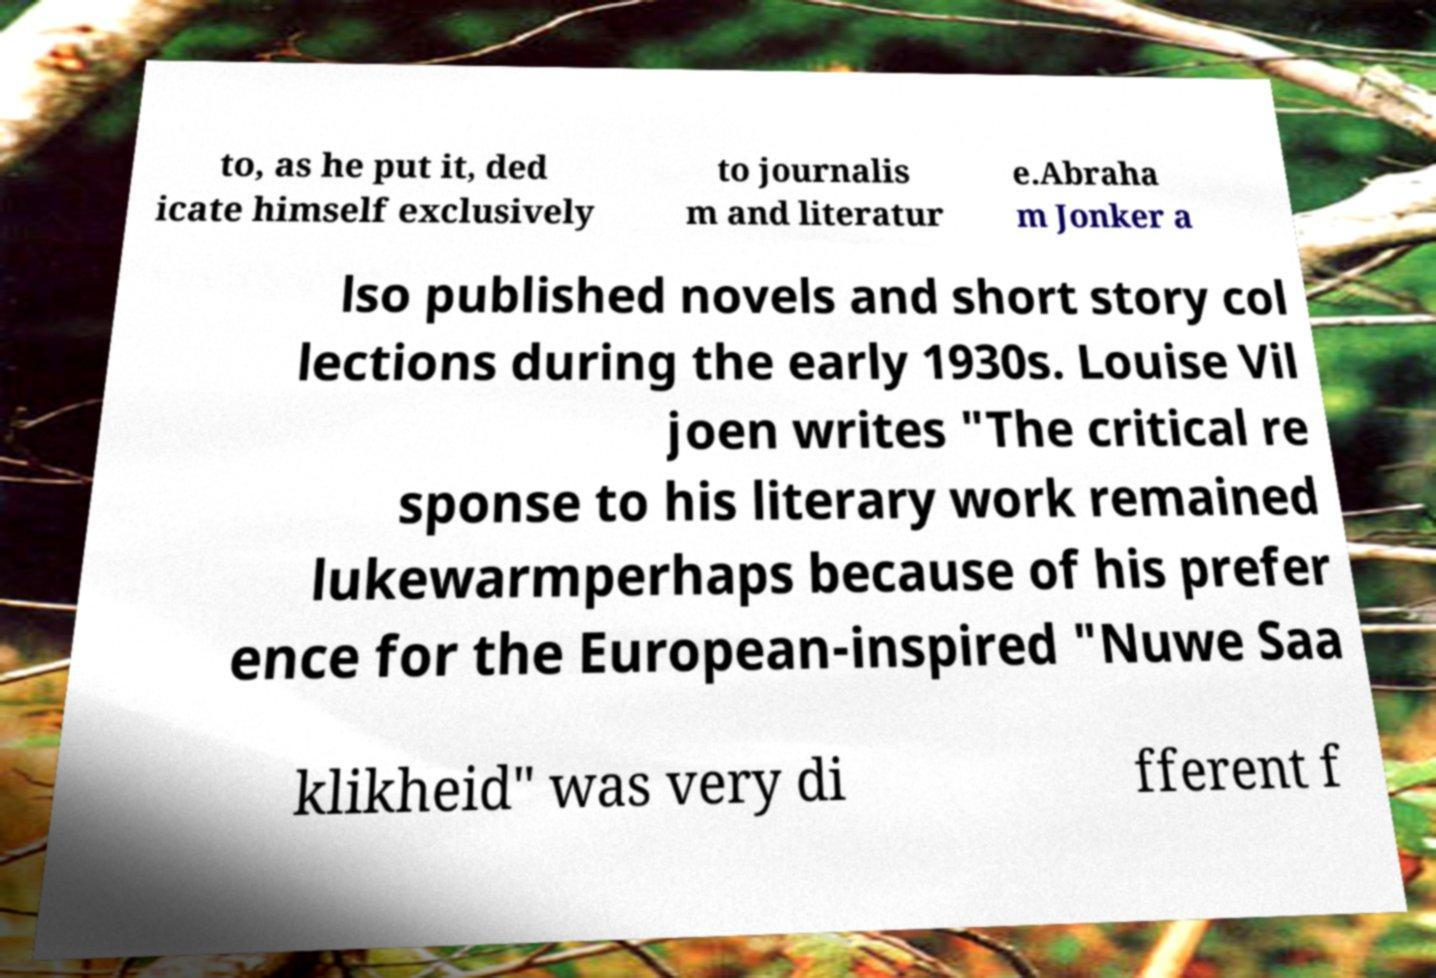Please identify and transcribe the text found in this image. to, as he put it, ded icate himself exclusively to journalis m and literatur e.Abraha m Jonker a lso published novels and short story col lections during the early 1930s. Louise Vil joen writes "The critical re sponse to his literary work remained lukewarmperhaps because of his prefer ence for the European-inspired "Nuwe Saa klikheid" was very di fferent f 